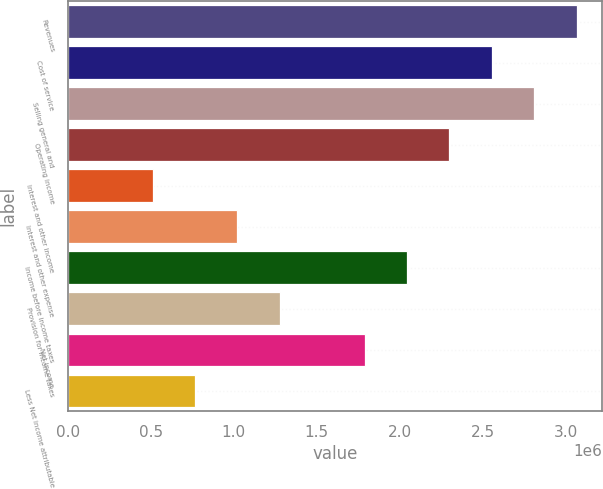Convert chart. <chart><loc_0><loc_0><loc_500><loc_500><bar_chart><fcel>Revenues<fcel>Cost of service<fcel>Selling general and<fcel>Operating income<fcel>Interest and other income<fcel>Interest and other expense<fcel>Income before income taxes<fcel>Provision for income taxes<fcel>Net income<fcel>Less Net income attributable<nl><fcel>3.06508e+06<fcel>2.55424e+06<fcel>2.80966e+06<fcel>2.29881e+06<fcel>510849<fcel>1.0217e+06<fcel>2.04339e+06<fcel>1.27712e+06<fcel>1.78797e+06<fcel>766272<nl></chart> 